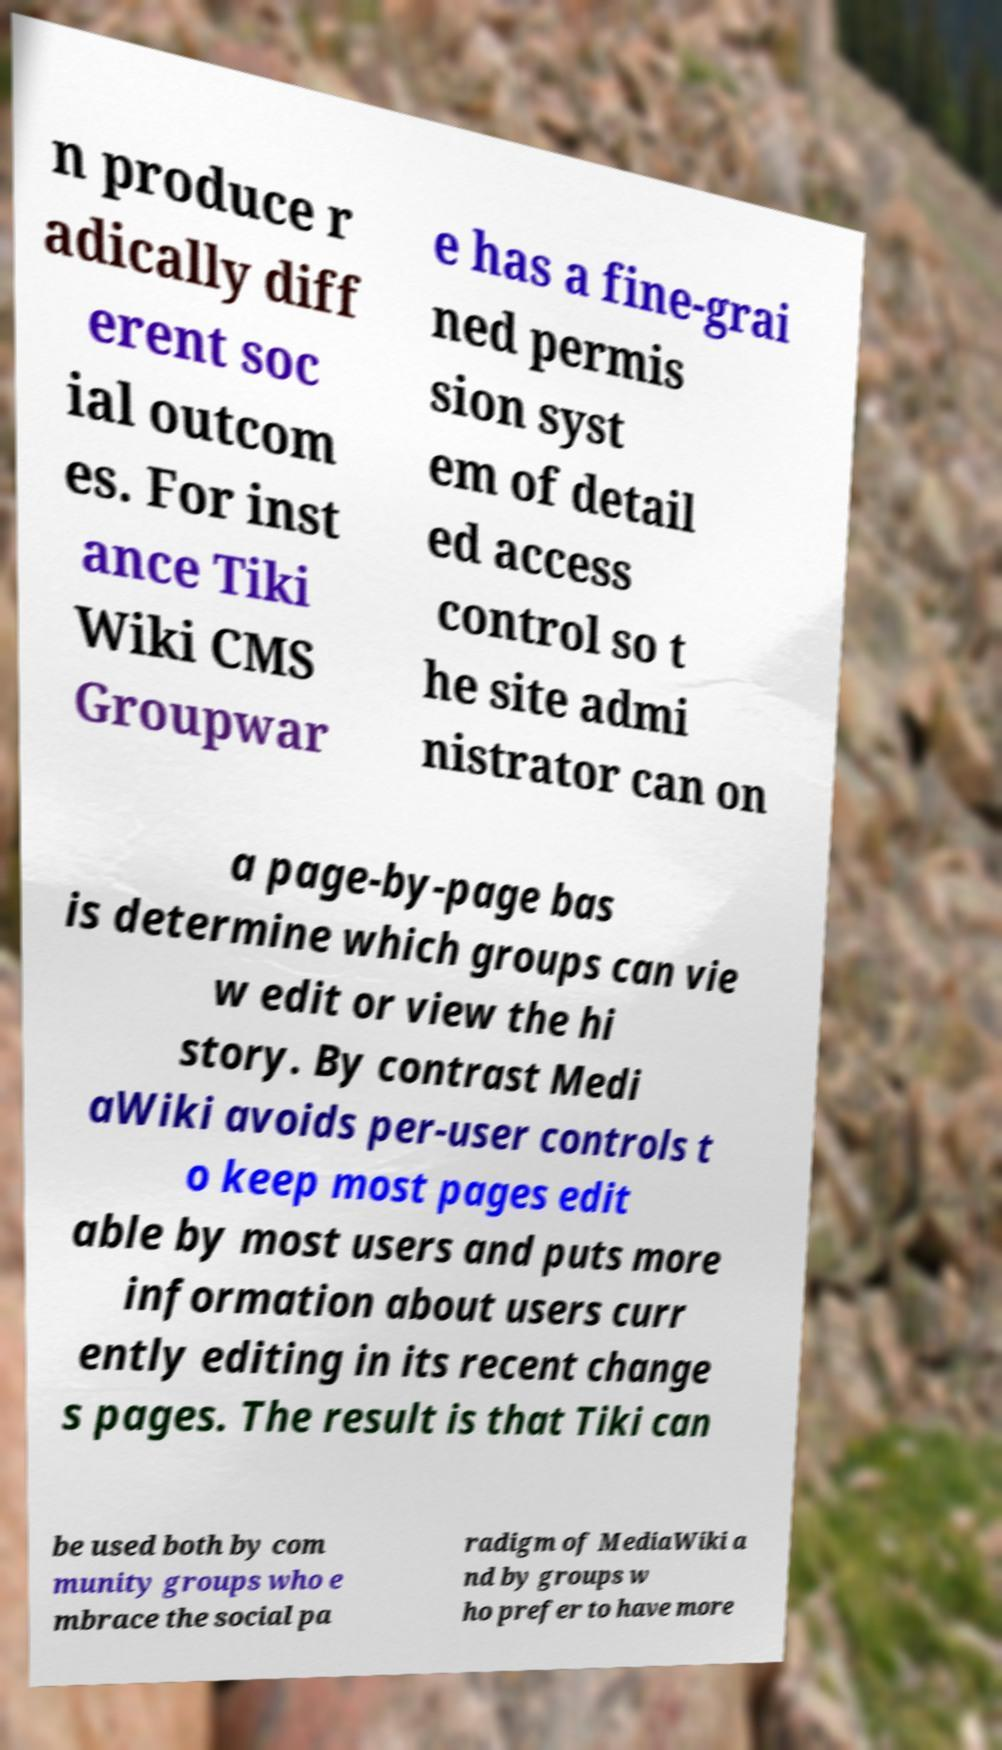Please read and relay the text visible in this image. What does it say? n produce r adically diff erent soc ial outcom es. For inst ance Tiki Wiki CMS Groupwar e has a fine-grai ned permis sion syst em of detail ed access control so t he site admi nistrator can on a page-by-page bas is determine which groups can vie w edit or view the hi story. By contrast Medi aWiki avoids per-user controls t o keep most pages edit able by most users and puts more information about users curr ently editing in its recent change s pages. The result is that Tiki can be used both by com munity groups who e mbrace the social pa radigm of MediaWiki a nd by groups w ho prefer to have more 